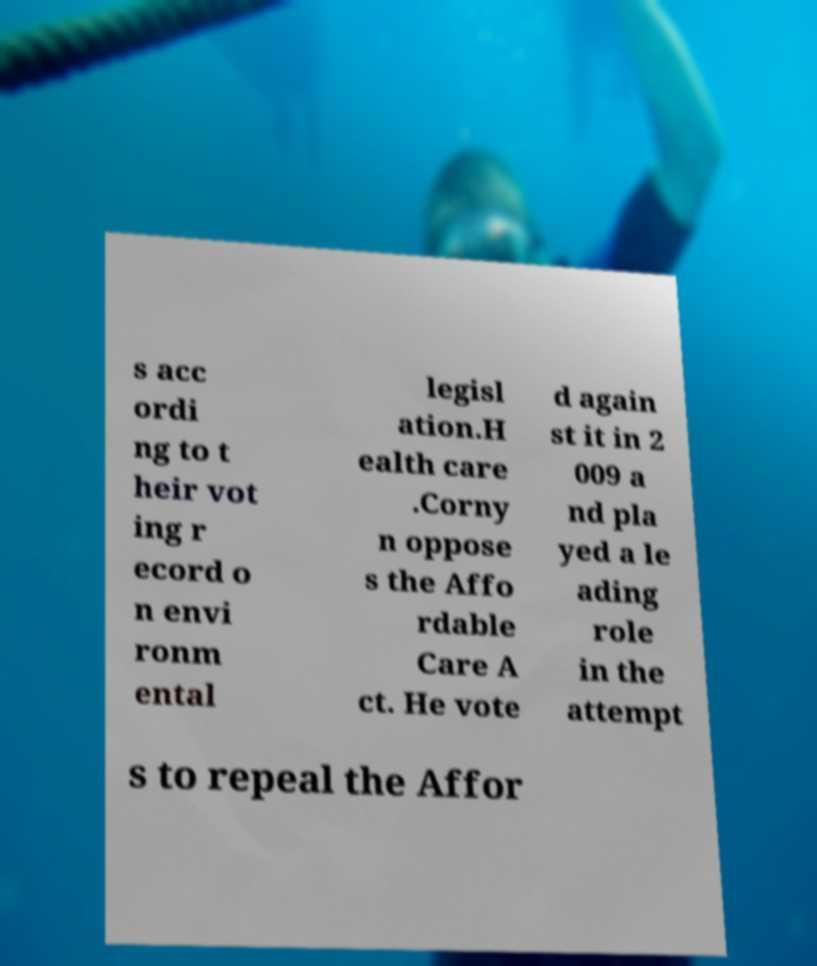Please read and relay the text visible in this image. What does it say? s acc ordi ng to t heir vot ing r ecord o n envi ronm ental legisl ation.H ealth care .Corny n oppose s the Affo rdable Care A ct. He vote d again st it in 2 009 a nd pla yed a le ading role in the attempt s to repeal the Affor 